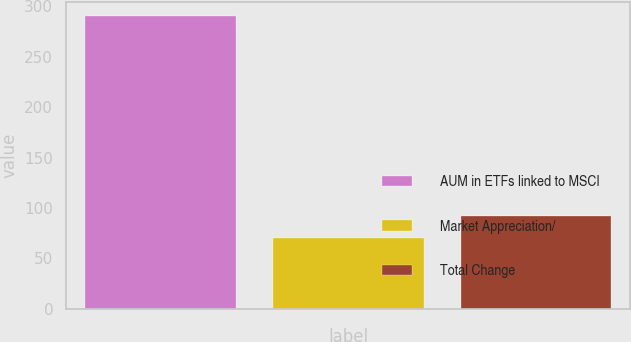<chart> <loc_0><loc_0><loc_500><loc_500><bar_chart><fcel>AUM in ETFs linked to MSCI<fcel>Market Appreciation/<fcel>Total Change<nl><fcel>290.1<fcel>70.4<fcel>92.37<nl></chart> 